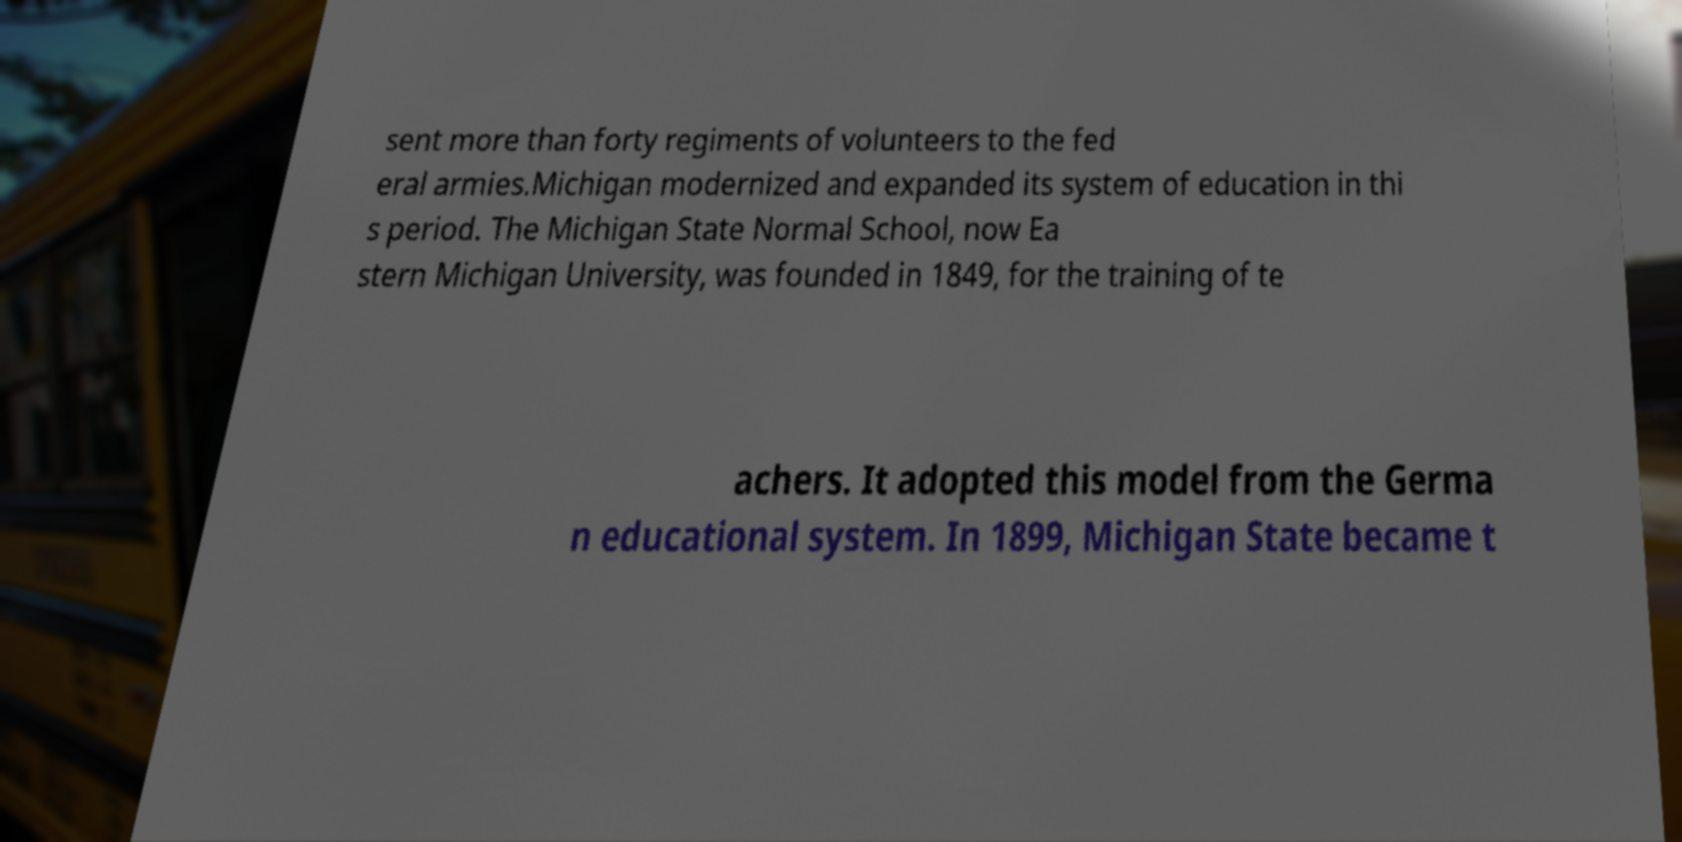Please read and relay the text visible in this image. What does it say? sent more than forty regiments of volunteers to the fed eral armies.Michigan modernized and expanded its system of education in thi s period. The Michigan State Normal School, now Ea stern Michigan University, was founded in 1849, for the training of te achers. It adopted this model from the Germa n educational system. In 1899, Michigan State became t 